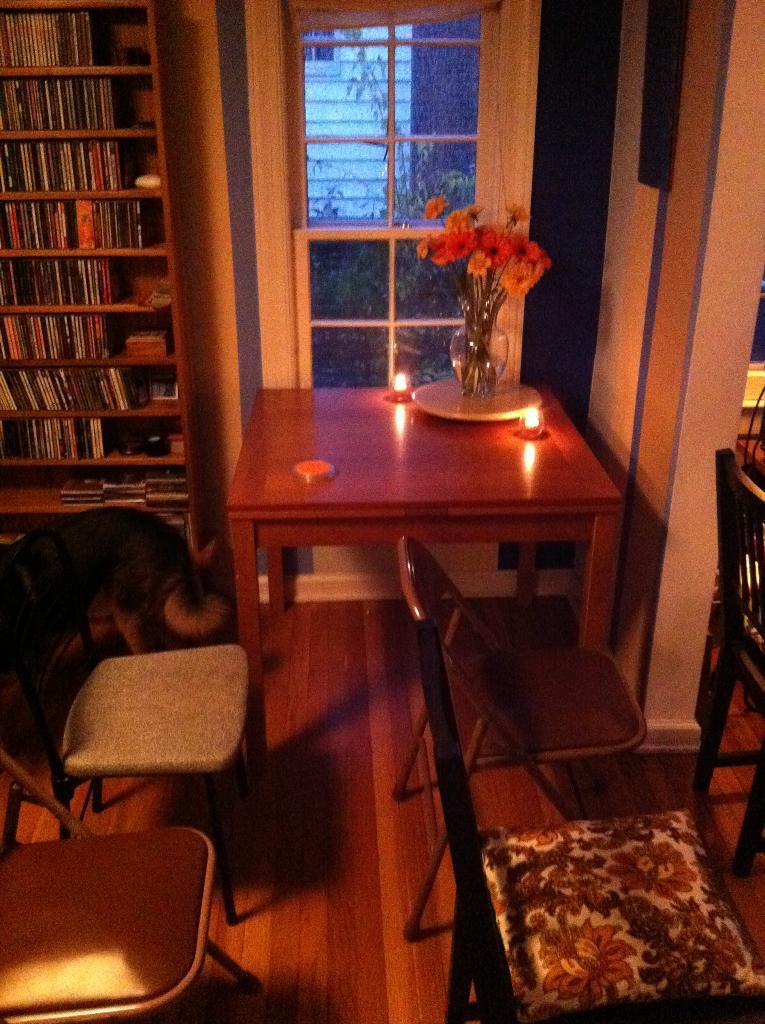How would you summarize this image in a sentence or two? This is a room. In this room there are five chairs. And there is a table. On the table there is a flower vase containing flowers and two lamps are there on the table. Near to the table there is a shelf containing books. In front of the shelf there is a dog. And in the background there is a door. 